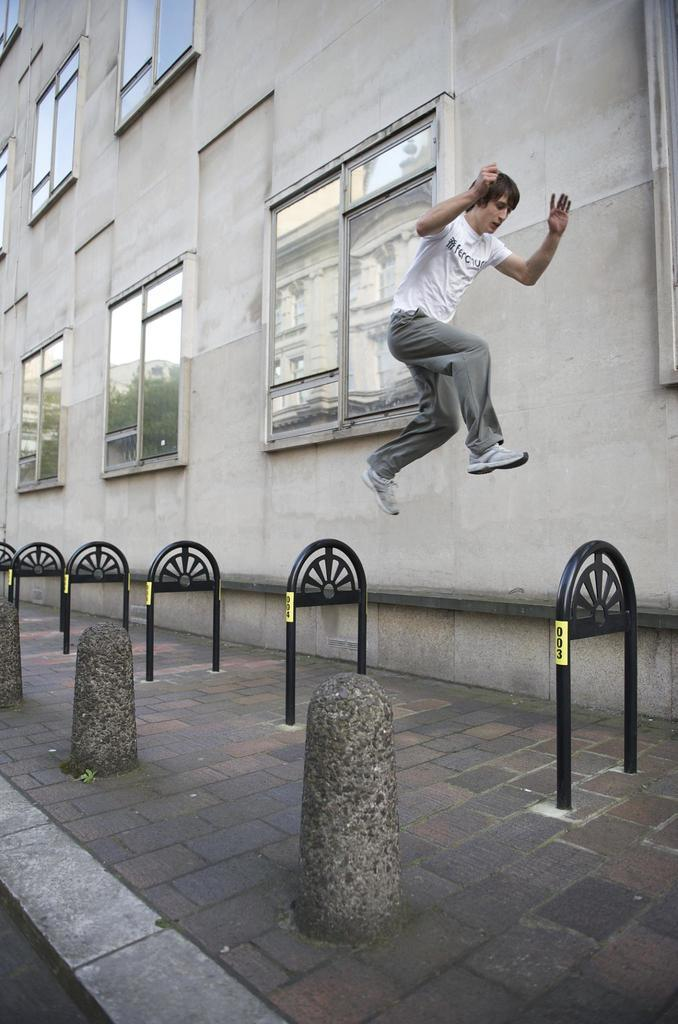What is the main subject of the image? There is a person in the image. What is the person doing in the image? The person is in the air. What is the person wearing in the image? The person is wearing a white shirt and gray pants. What can be seen in the background of the image? There is a building in the background of the image. What is the color of the building in the image? The building is gray in color. What feature of the building is visible in the image? There are glass windows visible on the building. What time of day is it in the image, and what is the person's son doing at that time? The time of day is not mentioned in the image, and there is no information about the person's son. 